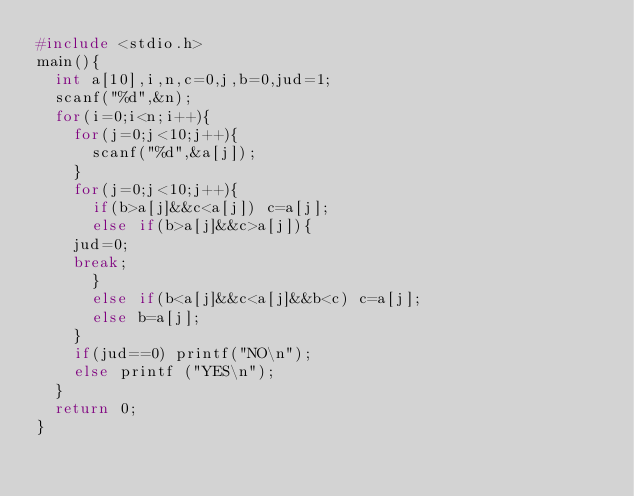<code> <loc_0><loc_0><loc_500><loc_500><_C_>#include <stdio.h>
main(){
  int a[10],i,n,c=0,j,b=0,jud=1;
  scanf("%d",&n);
  for(i=0;i<n;i++){
    for(j=0;j<10;j++){
      scanf("%d",&a[j]);
	}
    for(j=0;j<10;j++){
      if(b>a[j]&&c<a[j]) c=a[j];
      else if(b>a[j]&&c>a[j]){
	jud=0;
	break;
      }
      else if(b<a[j]&&c<a[j]&&b<c) c=a[j];
      else b=a[j];
    }
    if(jud==0) printf("NO\n");
    else printf ("YES\n");
  }
  return 0; 
}</code> 